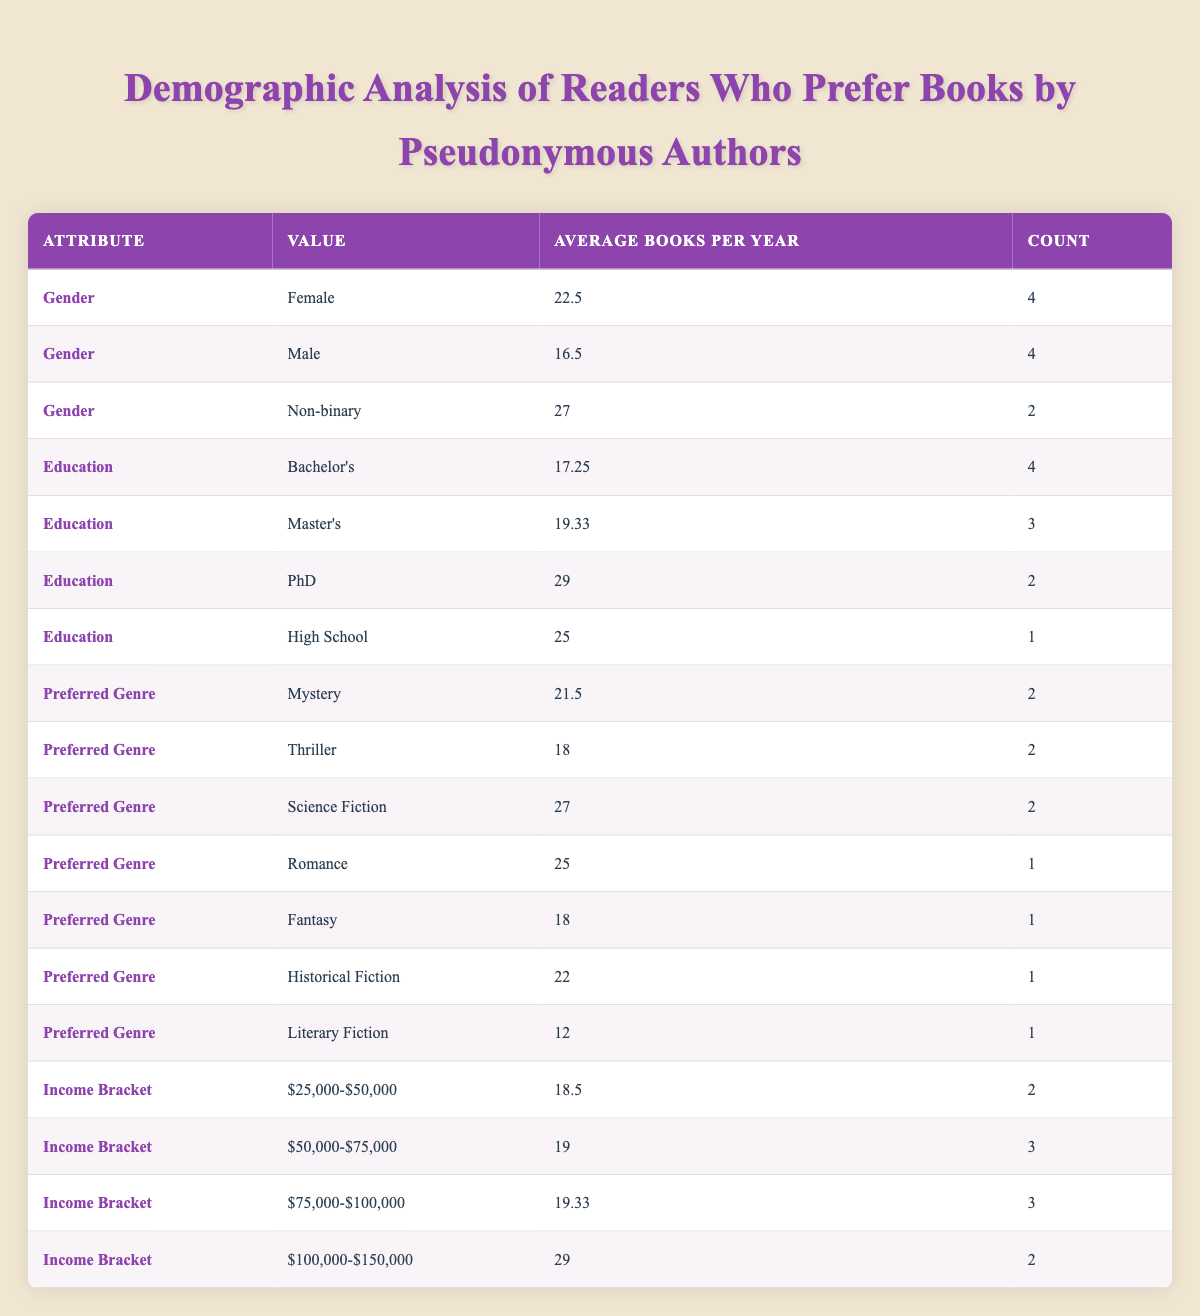What is the average number of books read per year by Female readers? To find the average for Female readers, we look at the corresponding row in the table where the gender is Female. The total number of Female readers is 4 with an average of 22.5 books per year.
Answer: 22.5 What is the highest average number of books read per year among Non-binary readers? There are two Non-binary readers in the table, with averages of 27 books read (one reader each for James S. A. Corey and Mira Grant). Thus, the highest average among Non-binary readers is 27.
Answer: 27 Are there more readers with a Master's degree or those with a Bachelor's degree? We examine the rows for each education level. There are 3 readers with a Master's degree and 4 readers with a Bachelor's degree. Therefore, there are more readers with a Bachelor's degree.
Answer: Yes What is the average number of books read per year for readers in the income bracket $75,000-$100,000? In the table, we locate the row for the income bracket $75,000-$100,000 and see there are 3 readers with an average of 19.33 books per year.
Answer: 19.33 Which preferred genre shows the highest average number of books read per year? We review the average books per year for each genre and find that Science Fiction shows an average of 27 books, which is the highest among other genres.
Answer: Science Fiction What is the count of readers who enjoy Romance as their preferred genre? By checking the table, we find that there is 1 reader who prefers Romance, as indicated in the relevant row.
Answer: 1 Is the average number of books read per year by Male readers higher than 18? The average for Male readers is 16.5, which is less than 18. Thus, the statement is false.
Answer: No Which income bracket has the highest average number of books read per year and what is that average? We look through the income brackets and their corresponding averages. The income bracket $100,000-$150,000 has the highest average of 29 books read per year.
Answer: $100,000-$150,000; 29 What is the overall average number of books read per year by all readers? First, calculate the total books read by all readers (15 + 20 + 30 + 25 + 18 + 22 + 12 + 28 + 16 + 24 =  220). Since there are 10 readers, the overall average is 220 / 10 = 22.
Answer: 22 